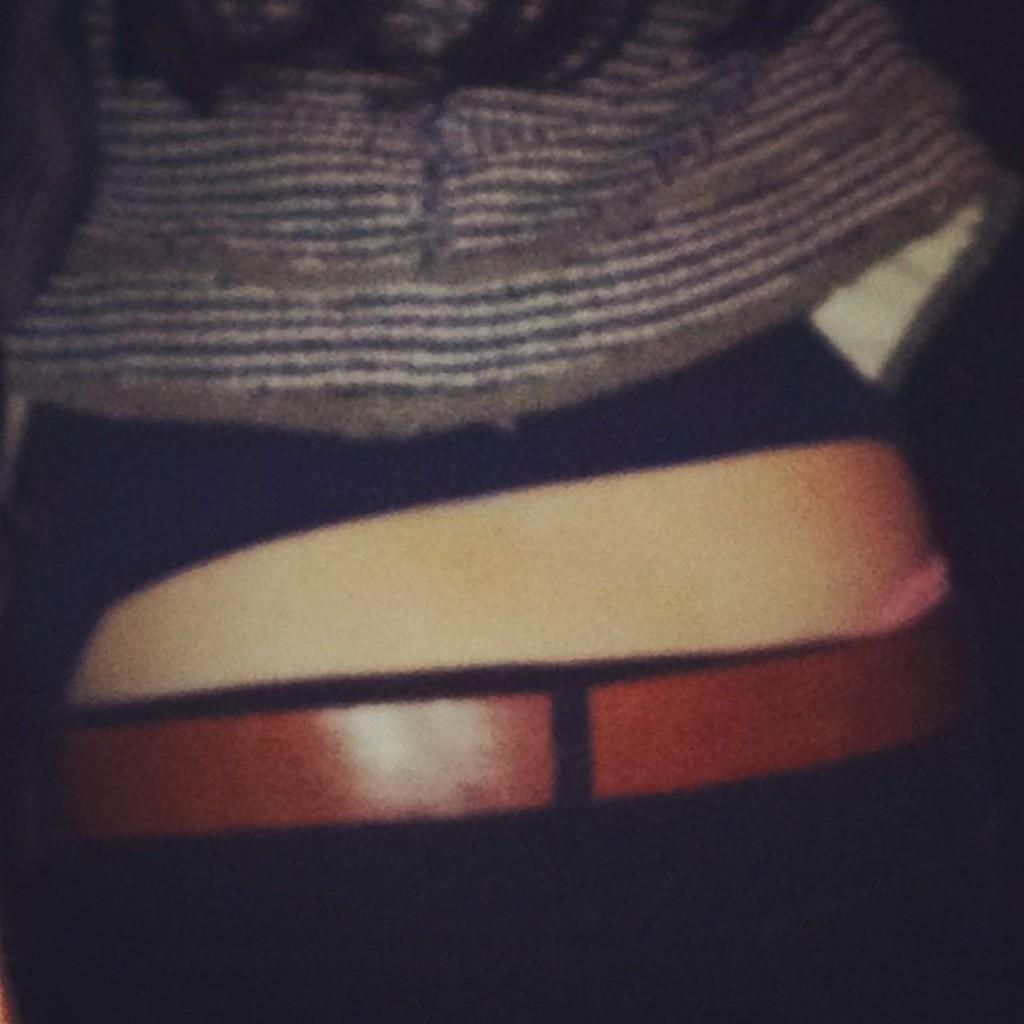How would you summarize this image in a sentence or two? In this image there is a person wearing belt and shirt. 